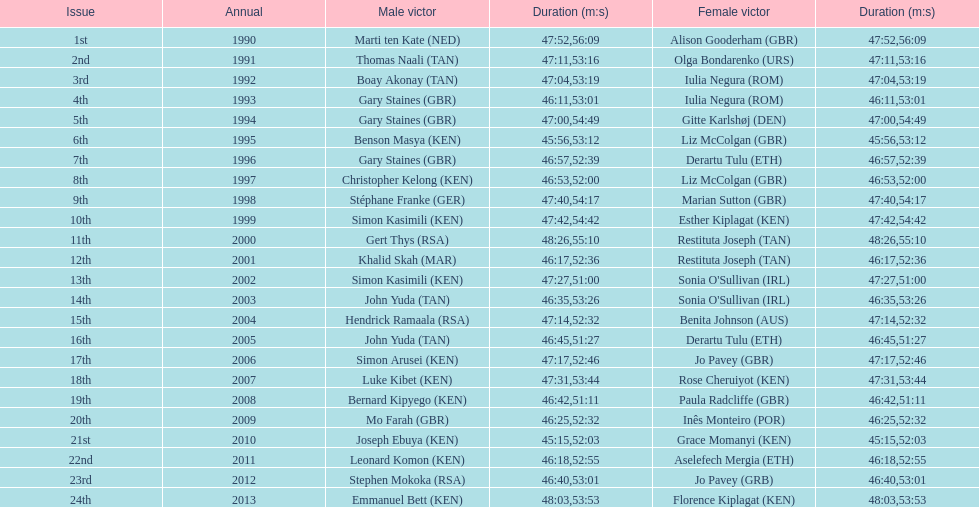How many men winners had times at least 46 minutes or under? 2. 